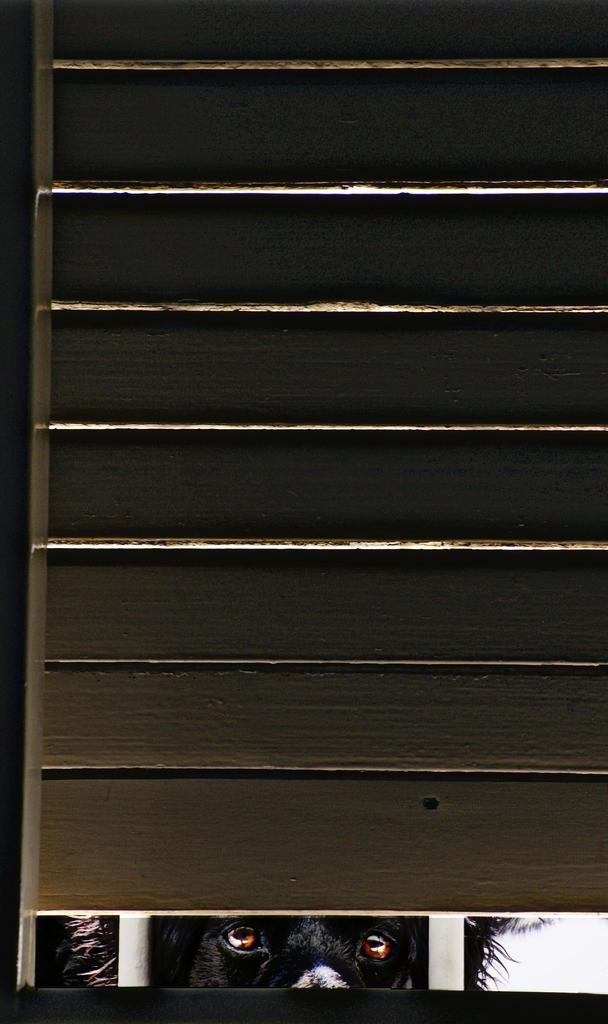Could you give a brief overview of what you see in this image? In this image we can see one black dog, two white poles and one object look like a door. 